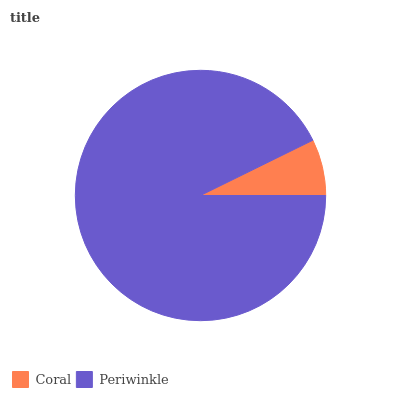Is Coral the minimum?
Answer yes or no. Yes. Is Periwinkle the maximum?
Answer yes or no. Yes. Is Periwinkle the minimum?
Answer yes or no. No. Is Periwinkle greater than Coral?
Answer yes or no. Yes. Is Coral less than Periwinkle?
Answer yes or no. Yes. Is Coral greater than Periwinkle?
Answer yes or no. No. Is Periwinkle less than Coral?
Answer yes or no. No. Is Periwinkle the high median?
Answer yes or no. Yes. Is Coral the low median?
Answer yes or no. Yes. Is Coral the high median?
Answer yes or no. No. Is Periwinkle the low median?
Answer yes or no. No. 